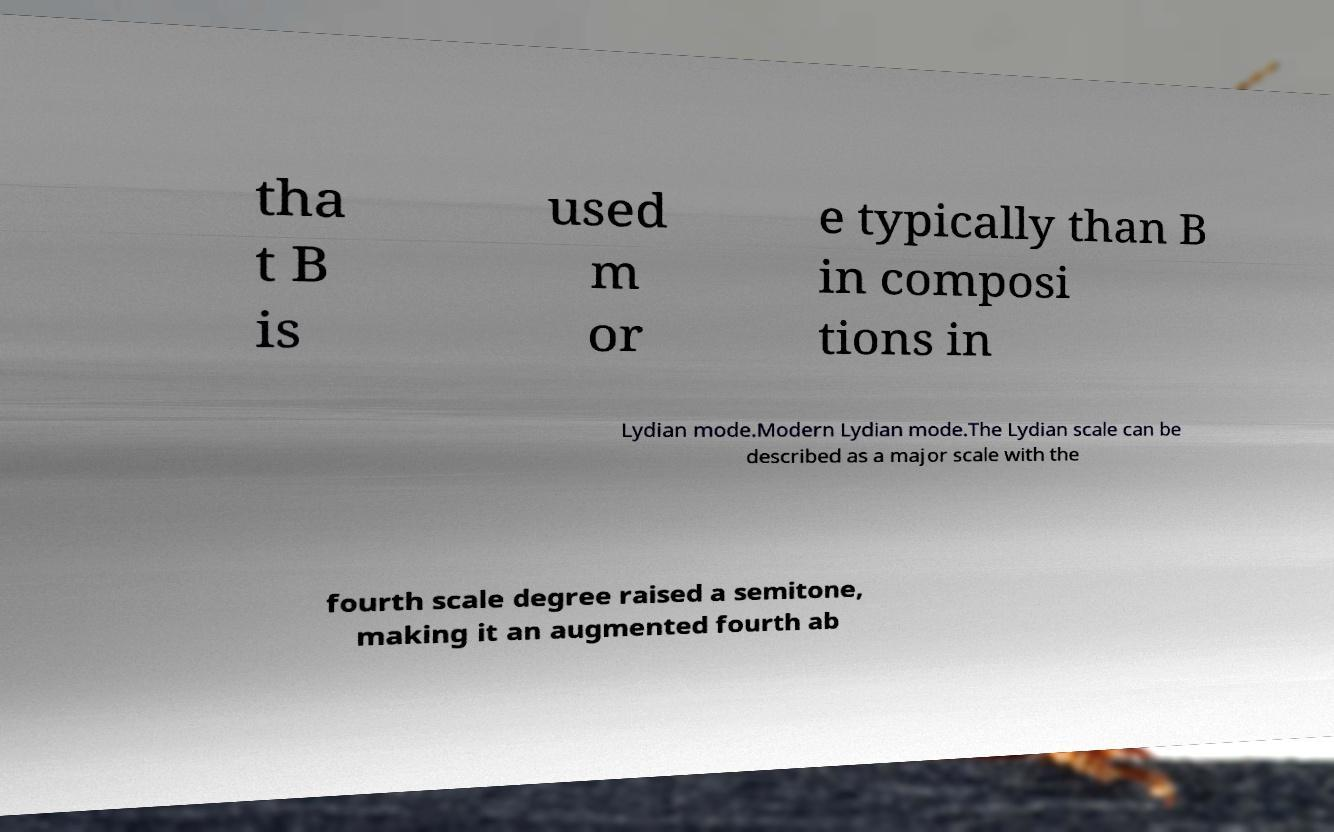For documentation purposes, I need the text within this image transcribed. Could you provide that? tha t B is used m or e typically than B in composi tions in Lydian mode.Modern Lydian mode.The Lydian scale can be described as a major scale with the fourth scale degree raised a semitone, making it an augmented fourth ab 